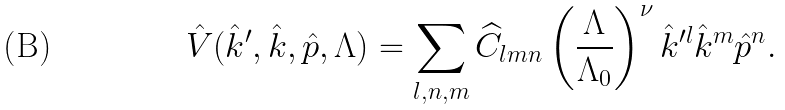Convert formula to latex. <formula><loc_0><loc_0><loc_500><loc_500>\hat { V } ( \hat { k } ^ { \prime } , \hat { k } , \hat { p } , \Lambda ) = \sum _ { l , n , m } \widehat { C } _ { l m n } \left ( { \frac { \Lambda } { \Lambda _ { 0 } } } \right ) ^ { \nu } \hat { k } ^ { \prime l } \hat { k } ^ { m } \hat { p } ^ { n } .</formula> 